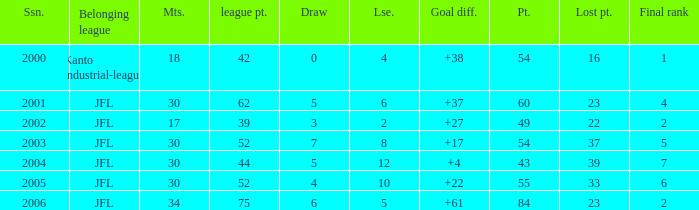I want the total number of matches for draw less than 7 and lost point of 16 with lose more than 4 0.0. 